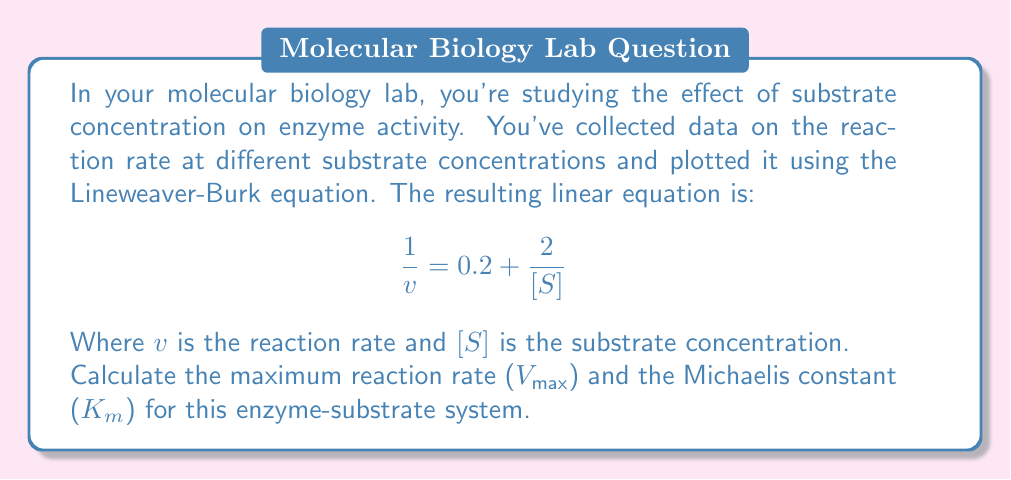Provide a solution to this math problem. To solve this problem, we need to understand the Lineweaver-Burk equation and how it relates to enzyme kinetics:

1. The Lineweaver-Burk equation is a linear transformation of the Michaelis-Menten equation:

   $$\frac{1}{v} = \frac{1}{V_{max}} + \frac{K_m}{V_{max}} \cdot \frac{1}{[S]}$$

2. This equation is in the form of $y = mx + b$, where:
   
   $y = \frac{1}{v}$
   $x = \frac{1}{[S]}$
   $m = \frac{K_m}{V_{max}}$
   $b = \frac{1}{V_{max}}$

3. From the given equation:

   $$\frac{1}{v} = 0.2 + \frac{2}{[S]}$$

   We can identify that:
   
   $b = 0.2$
   $m = 2$

4. To find $V_{max}$:
   
   $\frac{1}{V_{max}} = b = 0.2$
   $V_{max} = \frac{1}{0.2} = 5$

5. To find $K_m$:
   
   $\frac{K_m}{V_{max}} = m = 2$
   $K_m = 2 \cdot V_{max} = 2 \cdot 5 = 10$

Therefore, $V_{max} = 5$ and $K_m = 10$.
Answer: $V_{max} = 5$ (units depend on how reaction rate was measured)
$K_m = 10$ (units are the same as substrate concentration) 